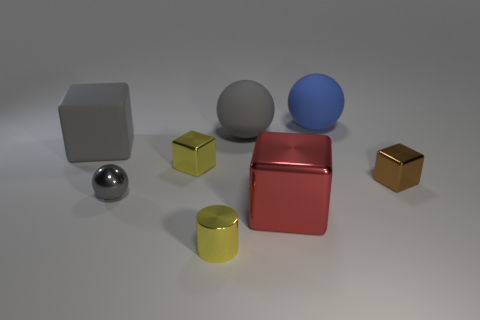Subtract all gray spheres. How many were subtracted if there are1gray spheres left? 1 Subtract all big matte spheres. How many spheres are left? 1 Subtract all gray blocks. How many blocks are left? 3 Add 2 brown cubes. How many objects exist? 10 Subtract all blue cylinders. How many gray spheres are left? 2 Add 6 blue spheres. How many blue spheres are left? 7 Add 6 purple balls. How many purple balls exist? 6 Subtract 0 purple blocks. How many objects are left? 8 Subtract all cylinders. How many objects are left? 7 Subtract 1 cylinders. How many cylinders are left? 0 